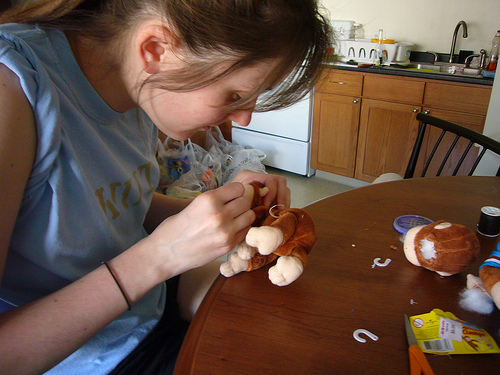<image>
Can you confirm if the toy is next to the toy? Yes. The toy is positioned adjacent to the toy, located nearby in the same general area. 